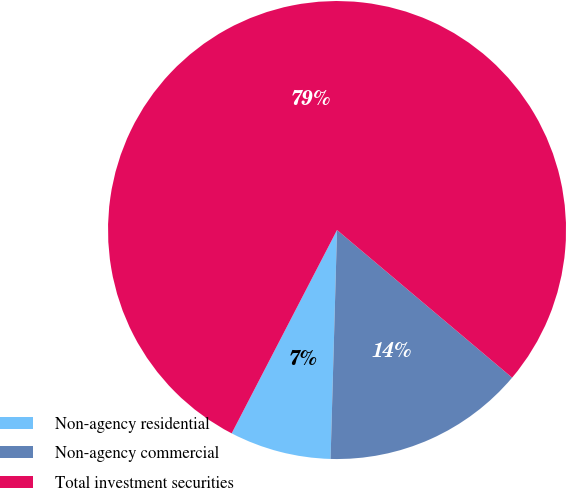<chart> <loc_0><loc_0><loc_500><loc_500><pie_chart><fcel>Non-agency residential<fcel>Non-agency commercial<fcel>Total investment securities<nl><fcel>7.16%<fcel>14.3%<fcel>78.54%<nl></chart> 